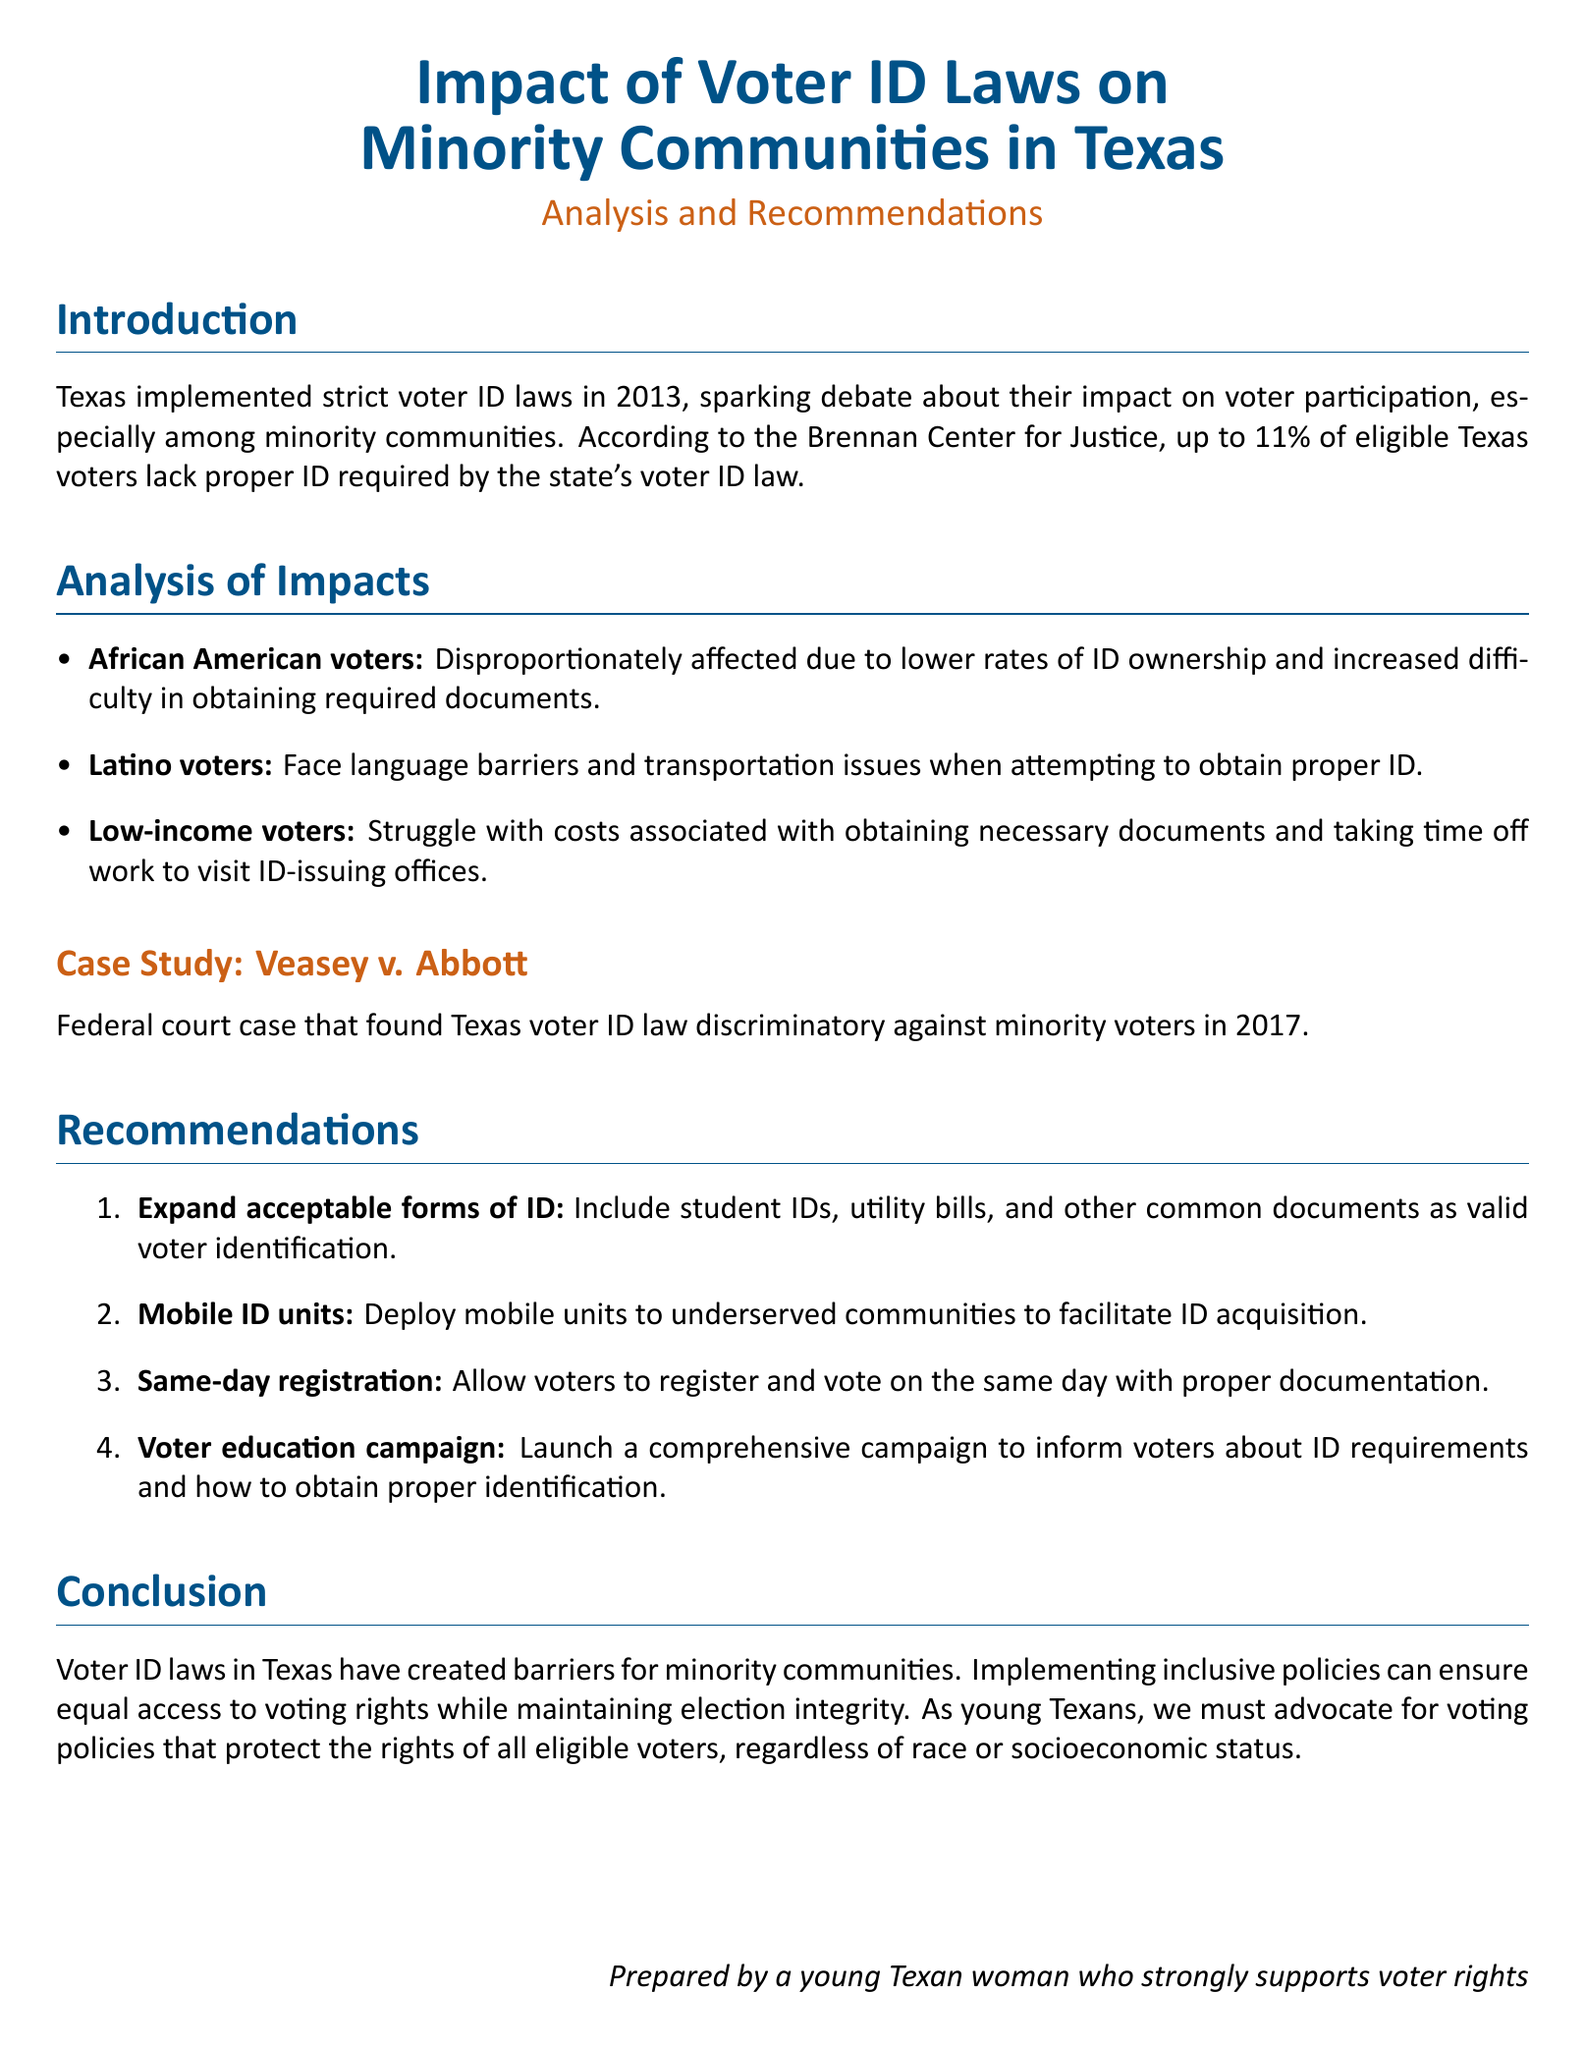What year were the strict voter ID laws implemented in Texas? The document states that Texas implemented strict voter ID laws in 2013.
Answer: 2013 What percentage of eligible Texas voters lack proper ID? According to the Brennan Center for Justice mentioned in the document, up to 11% of eligible Texas voters lack proper ID.
Answer: 11% Which federal court case found the Texas voter ID law discriminatory? The document references the case of Veasey v. Abbott as the federal court case that found the law discriminatory against minority voters.
Answer: Veasey v. Abbott What is one reason African American voters are disproportionately affected by voter ID laws? The document indicates that African American voters are affected due to lower rates of ID ownership and increased difficulty in obtaining required documents.
Answer: Lower rates of ID ownership What is one recommendation provided in the document to improve access to voter ID? One recommendation is to deploy mobile units to underserved communities to facilitate ID acquisition.
Answer: Mobile ID units What are the two challenges faced by Latino voters when obtaining proper ID? The document notes that Latino voters face language barriers and transportation issues when attempting to obtain proper ID.
Answer: Language barriers and transportation issues What is the main conclusion drawn in the document regarding voter ID laws? The conclusion is that voter ID laws in Texas have created barriers for minority communities.
Answer: Barriers for minority communities What type of campaign is recommended to inform voters about ID requirements? The document recommends launching a comprehensive voter education campaign to inform voters about ID requirements.
Answer: Voter education campaign 